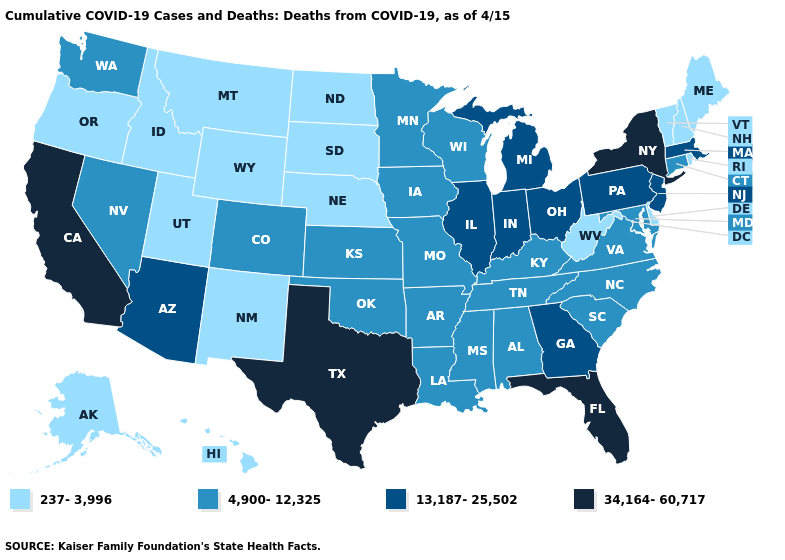How many symbols are there in the legend?
Short answer required. 4. What is the lowest value in states that border North Carolina?
Be succinct. 4,900-12,325. What is the lowest value in states that border Arkansas?
Concise answer only. 4,900-12,325. How many symbols are there in the legend?
Answer briefly. 4. What is the value of Oklahoma?
Answer briefly. 4,900-12,325. Does Idaho have the highest value in the West?
Concise answer only. No. Among the states that border New York , does New Jersey have the highest value?
Write a very short answer. Yes. Which states hav the highest value in the West?
Quick response, please. California. Name the states that have a value in the range 237-3,996?
Concise answer only. Alaska, Delaware, Hawaii, Idaho, Maine, Montana, Nebraska, New Hampshire, New Mexico, North Dakota, Oregon, Rhode Island, South Dakota, Utah, Vermont, West Virginia, Wyoming. Which states have the lowest value in the Northeast?
Give a very brief answer. Maine, New Hampshire, Rhode Island, Vermont. What is the highest value in the USA?
Concise answer only. 34,164-60,717. Does California have the highest value in the West?
Be succinct. Yes. Does the first symbol in the legend represent the smallest category?
Concise answer only. Yes. Name the states that have a value in the range 34,164-60,717?
Give a very brief answer. California, Florida, New York, Texas. 